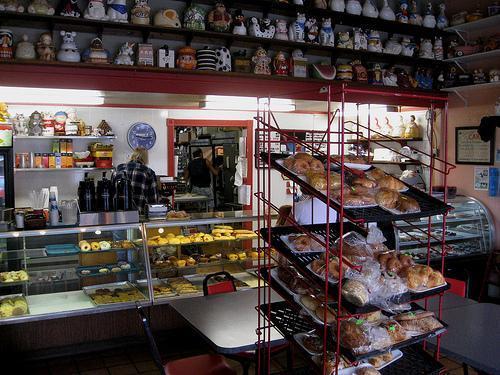How many people are in this photo?
Give a very brief answer. 2. 